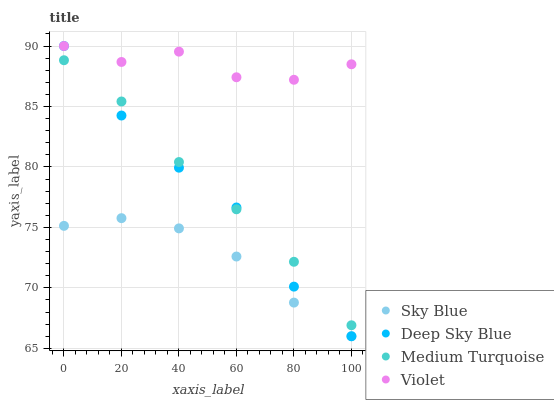Does Sky Blue have the minimum area under the curve?
Answer yes or no. Yes. Does Violet have the maximum area under the curve?
Answer yes or no. Yes. Does Medium Turquoise have the minimum area under the curve?
Answer yes or no. No. Does Medium Turquoise have the maximum area under the curve?
Answer yes or no. No. Is Medium Turquoise the smoothest?
Answer yes or no. Yes. Is Violet the roughest?
Answer yes or no. Yes. Is Deep Sky Blue the smoothest?
Answer yes or no. No. Is Deep Sky Blue the roughest?
Answer yes or no. No. Does Sky Blue have the lowest value?
Answer yes or no. Yes. Does Medium Turquoise have the lowest value?
Answer yes or no. No. Does Violet have the highest value?
Answer yes or no. Yes. Does Medium Turquoise have the highest value?
Answer yes or no. No. Is Sky Blue less than Medium Turquoise?
Answer yes or no. Yes. Is Violet greater than Medium Turquoise?
Answer yes or no. Yes. Does Deep Sky Blue intersect Violet?
Answer yes or no. Yes. Is Deep Sky Blue less than Violet?
Answer yes or no. No. Is Deep Sky Blue greater than Violet?
Answer yes or no. No. Does Sky Blue intersect Medium Turquoise?
Answer yes or no. No. 